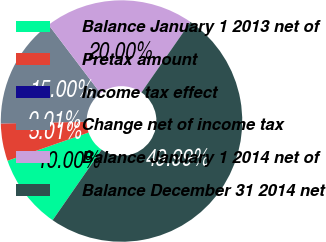<chart> <loc_0><loc_0><loc_500><loc_500><pie_chart><fcel>Balance January 1 2013 net of<fcel>Pretax amount<fcel>Income tax effect<fcel>Change net of income tax<fcel>Balance January 1 2014 net of<fcel>Balance December 31 2014 net<nl><fcel>10.0%<fcel>5.01%<fcel>0.01%<fcel>15.0%<fcel>20.0%<fcel>49.99%<nl></chart> 